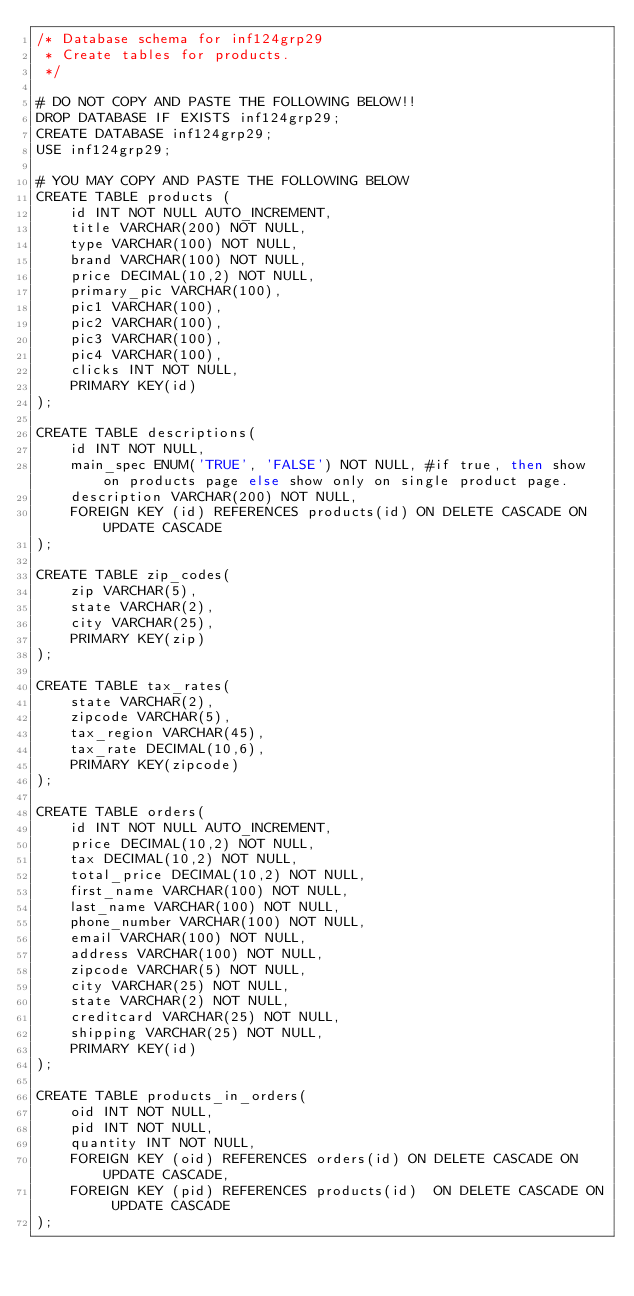Convert code to text. <code><loc_0><loc_0><loc_500><loc_500><_SQL_>/* Database schema for inf124grp29
 * Create tables for products.
 */
 
# DO NOT COPY AND PASTE THE FOLLOWING BELOW!!
DROP DATABASE IF EXISTS inf124grp29;
CREATE DATABASE inf124grp29;
USE inf124grp29;
 
# YOU MAY COPY AND PASTE THE FOLLOWING BELOW
CREATE TABLE products (
	id INT NOT NULL AUTO_INCREMENT,
    title VARCHAR(200) NOT NULL,
    type VARCHAR(100) NOT NULL,
    brand VARCHAR(100) NOT NULL,
    price DECIMAL(10,2) NOT NULL,
    primary_pic VARCHAR(100),
    pic1 VARCHAR(100),
    pic2 VARCHAR(100),
    pic3 VARCHAR(100),
    pic4 VARCHAR(100),
    clicks INT NOT NULL,
    PRIMARY KEY(id)
);

CREATE TABLE descriptions(
	id INT NOT NULL,
    main_spec ENUM('TRUE', 'FALSE') NOT NULL, #if true, then show on products page else show only on single product page.
    description VARCHAR(200) NOT NULL,
    FOREIGN KEY (id) REFERENCES products(id) ON DELETE CASCADE ON UPDATE CASCADE
);

CREATE TABLE zip_codes(
	zip VARCHAR(5),
	state VARCHAR(2),
	city VARCHAR(25),
    PRIMARY KEY(zip)
);

CREATE TABLE tax_rates(
	state VARCHAR(2),
	zipcode VARCHAR(5),
	tax_region VARCHAR(45),
	tax_rate DECIMAL(10,6),
    PRIMARY KEY(zipcode)
);

CREATE TABLE orders(
	id INT NOT NULL AUTO_INCREMENT,
    price DECIMAL(10,2) NOT NULL, 
    tax DECIMAL(10,2) NOT NULL,
    total_price DECIMAL(10,2) NOT NULL,    
    first_name VARCHAR(100) NOT NULL,
    last_name VARCHAR(100) NOT NULL,
    phone_number VARCHAR(100) NOT NULL,
    email VARCHAR(100) NOT NULL,
    address VARCHAR(100) NOT NULL,
    zipcode VARCHAR(5) NOT NULL,
    city VARCHAR(25) NOT NULL,
    state VARCHAR(2) NOT NULL,
    creditcard VARCHAR(25) NOT NULL,
    shipping VARCHAR(25) NOT NULL,
    PRIMARY KEY(id)
);

CREATE TABLE products_in_orders(
	oid INT NOT NULL,
    pid INT NOT NULL,
    quantity INT NOT NULL,
    FOREIGN KEY (oid) REFERENCES orders(id) ON DELETE CASCADE ON UPDATE CASCADE,
    FOREIGN KEY (pid) REFERENCES products(id)  ON DELETE CASCADE ON UPDATE CASCADE
);</code> 